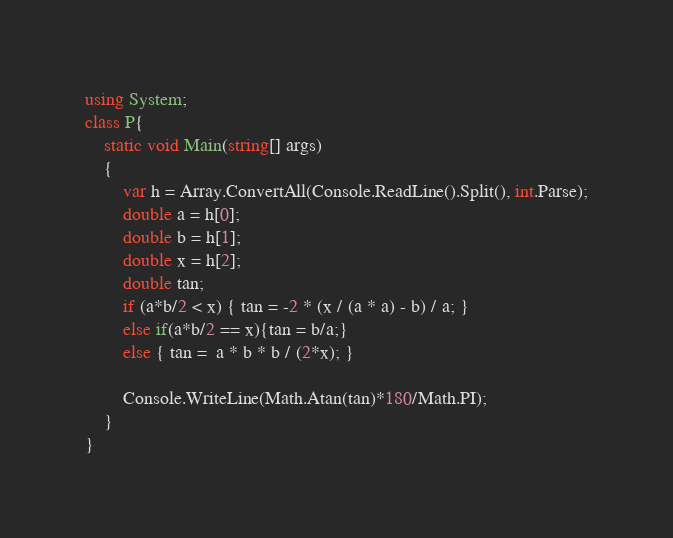<code> <loc_0><loc_0><loc_500><loc_500><_C#_>using System;
class P{
    static void Main(string[] args)
    {
        var h = Array.ConvertAll(Console.ReadLine().Split(), int.Parse);
        double a = h[0];
        double b = h[1];
        double x = h[2];
        double tan;
        if (a*b/2 < x) { tan = -2 * (x / (a * a) - b) / a; }
        else if(a*b/2 == x){tan = b/a;}
        else { tan =  a * b * b / (2*x); }
            
        Console.WriteLine(Math.Atan(tan)*180/Math.PI);
    }
}</code> 